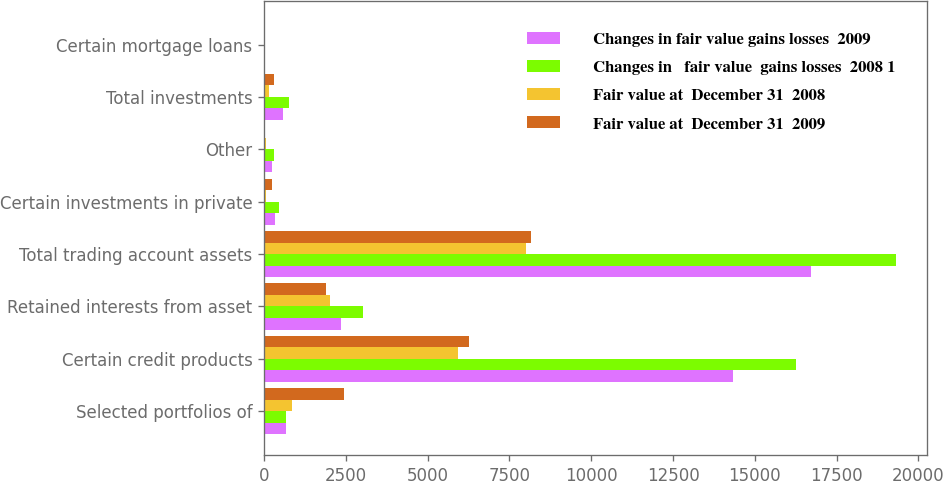<chart> <loc_0><loc_0><loc_500><loc_500><stacked_bar_chart><ecel><fcel>Selected portfolios of<fcel>Certain credit products<fcel>Retained interests from asset<fcel>Total trading account assets<fcel>Certain investments in private<fcel>Other<fcel>Total investments<fcel>Certain mortgage loans<nl><fcel>Changes in fair value gains losses  2009<fcel>669<fcel>14338<fcel>2357<fcel>16725<fcel>321<fcel>253<fcel>574<fcel>34<nl><fcel>Changes in   fair value  gains losses  2008 1<fcel>669<fcel>16254<fcel>3026<fcel>19313<fcel>469<fcel>295<fcel>764<fcel>36<nl><fcel>Fair value at  December 31  2008<fcel>864<fcel>5916<fcel>2024<fcel>8004<fcel>67<fcel>70<fcel>137<fcel>3<nl><fcel>Fair value at  December 31  2009<fcel>2438<fcel>6272<fcel>1890<fcel>8172<fcel>254<fcel>35<fcel>289<fcel>34<nl></chart> 